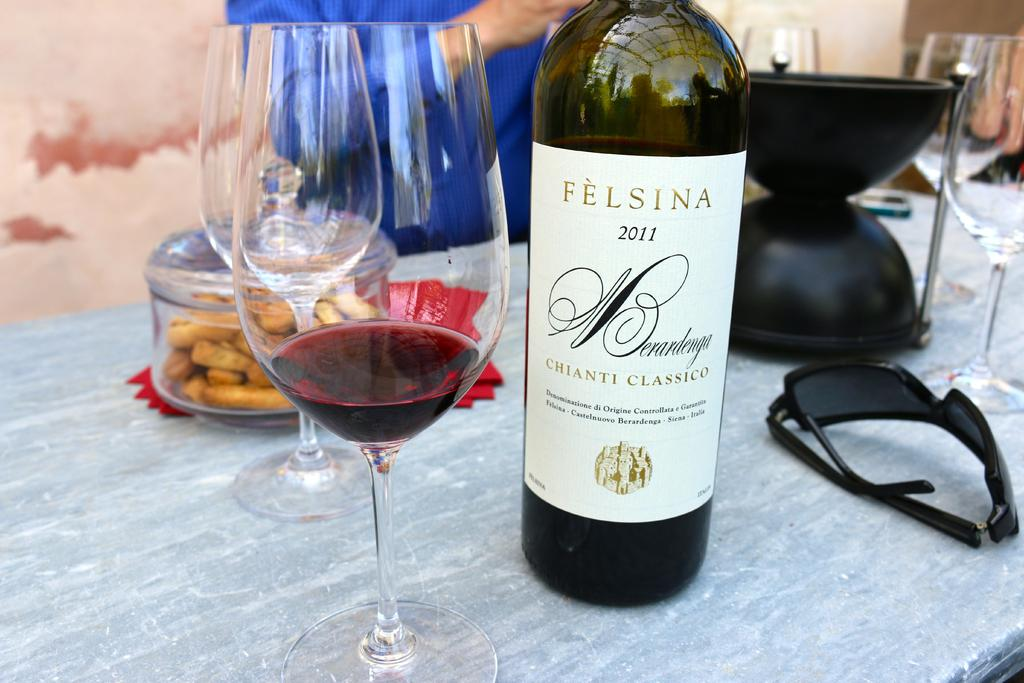<image>
Describe the image concisely. the word felsina that is on a bottle 